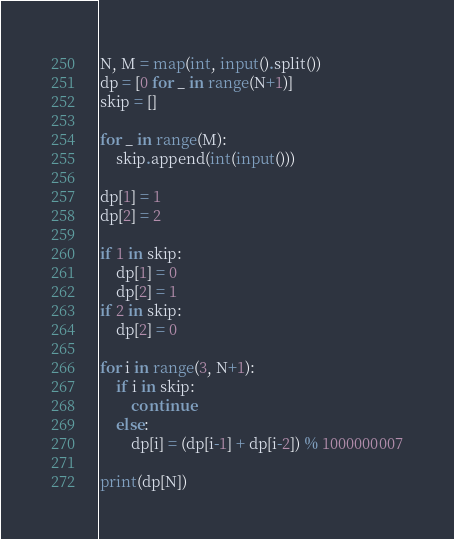Convert code to text. <code><loc_0><loc_0><loc_500><loc_500><_Python_>N, M = map(int, input().split())
dp = [0 for _ in range(N+1)]
skip = []

for _ in range(M):
    skip.append(int(input()))

dp[1] = 1
dp[2] = 2

if 1 in skip:
    dp[1] = 0
    dp[2] = 1
if 2 in skip:
    dp[2] = 0

for i in range(3, N+1):
    if i in skip:
        continue
    else:
        dp[i] = (dp[i-1] + dp[i-2]) % 1000000007

print(dp[N])
</code> 